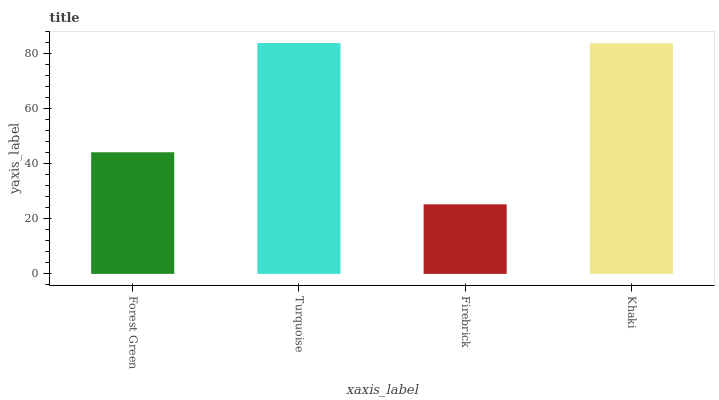Is Firebrick the minimum?
Answer yes or no. Yes. Is Turquoise the maximum?
Answer yes or no. Yes. Is Turquoise the minimum?
Answer yes or no. No. Is Firebrick the maximum?
Answer yes or no. No. Is Turquoise greater than Firebrick?
Answer yes or no. Yes. Is Firebrick less than Turquoise?
Answer yes or no. Yes. Is Firebrick greater than Turquoise?
Answer yes or no. No. Is Turquoise less than Firebrick?
Answer yes or no. No. Is Khaki the high median?
Answer yes or no. Yes. Is Forest Green the low median?
Answer yes or no. Yes. Is Firebrick the high median?
Answer yes or no. No. Is Turquoise the low median?
Answer yes or no. No. 